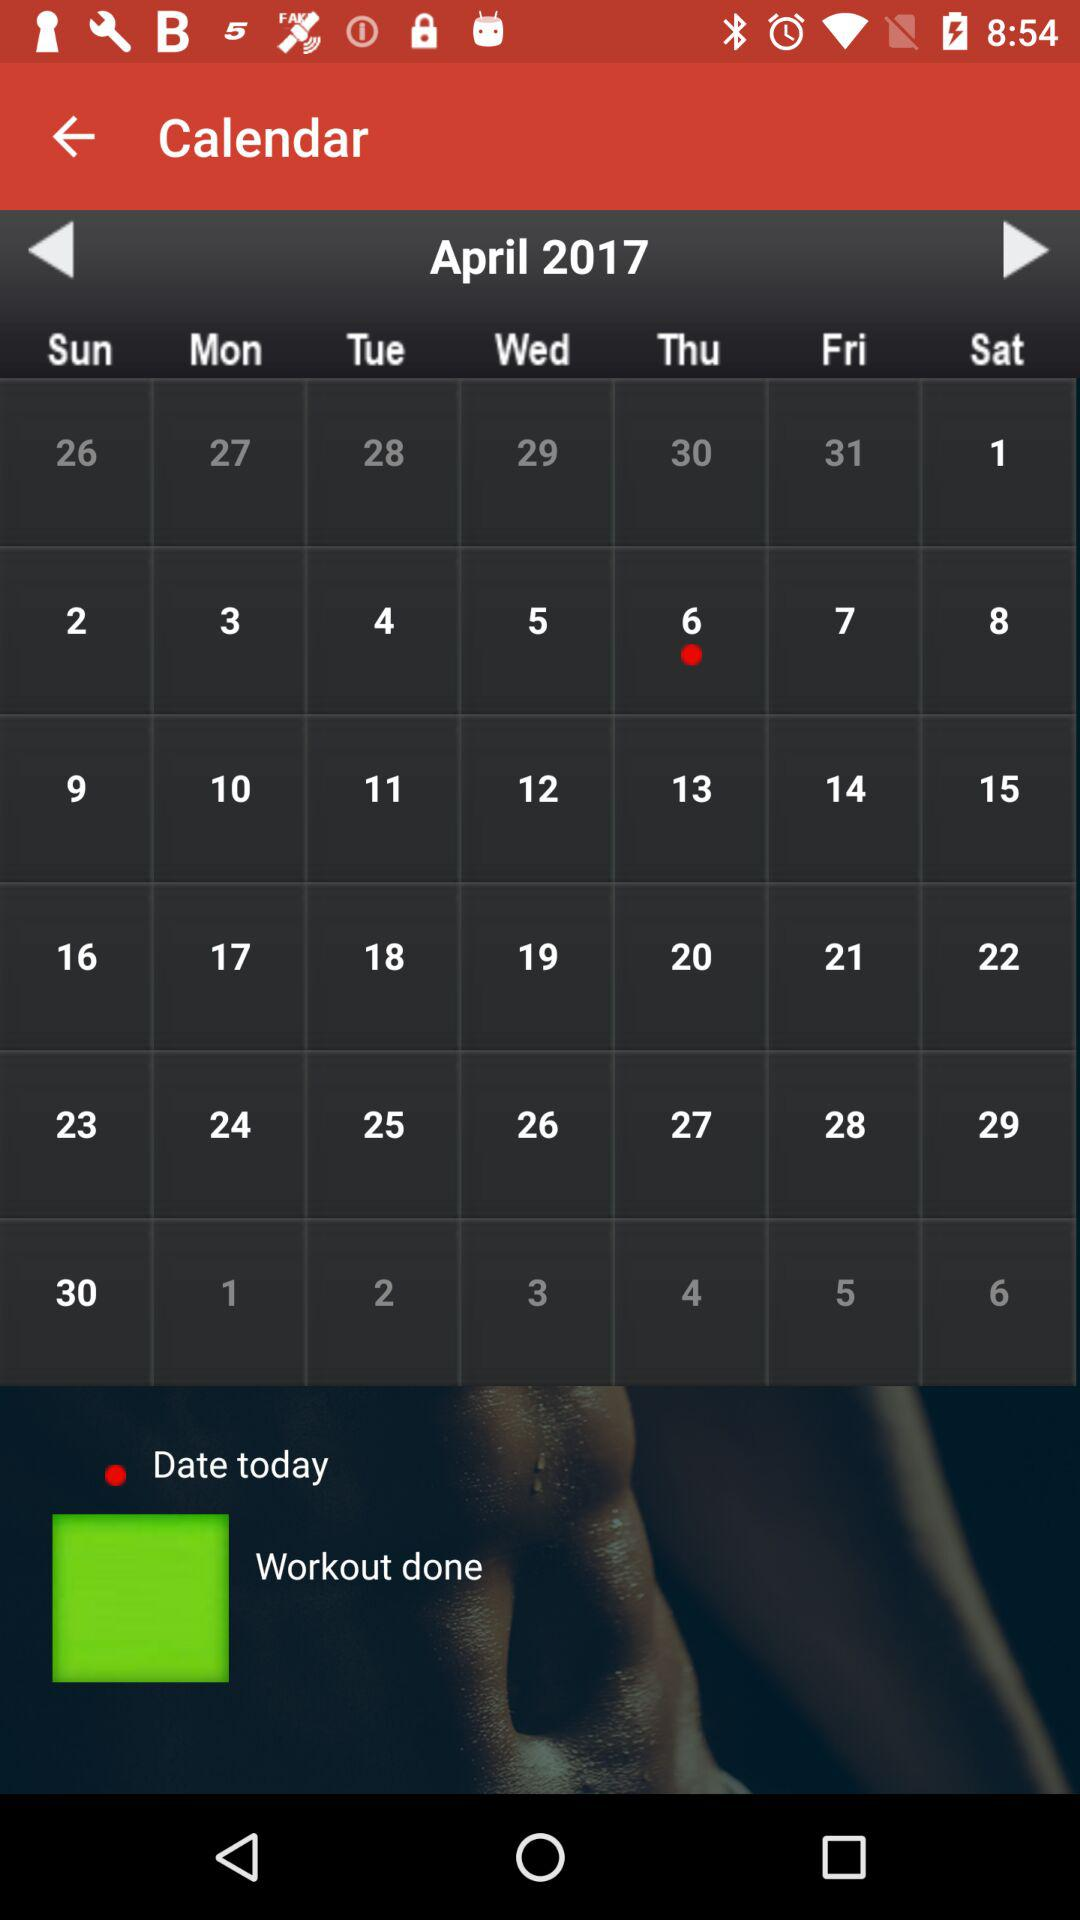What is the given month? The given month is April. 